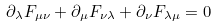Convert formula to latex. <formula><loc_0><loc_0><loc_500><loc_500>\partial _ { \lambda } F _ { \mu \nu } + \partial _ { \mu } F _ { \nu \lambda } + \partial _ { \nu } F _ { \lambda \mu } = 0</formula> 